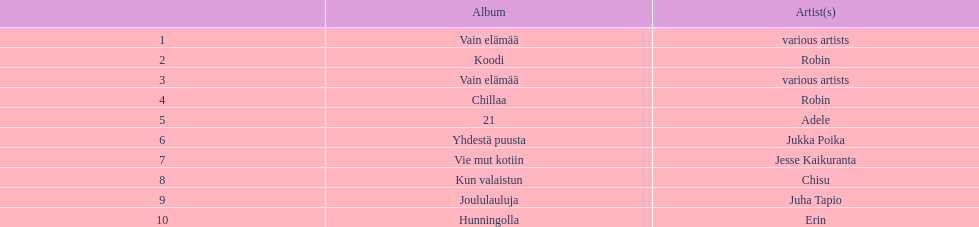Tell me what album had the most sold. Vain elämää. 